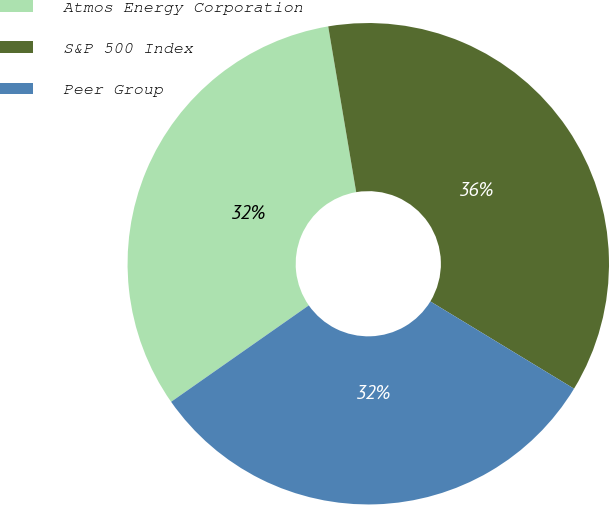Convert chart to OTSL. <chart><loc_0><loc_0><loc_500><loc_500><pie_chart><fcel>Atmos Energy Corporation<fcel>S&P 500 Index<fcel>Peer Group<nl><fcel>32.06%<fcel>36.35%<fcel>31.59%<nl></chart> 